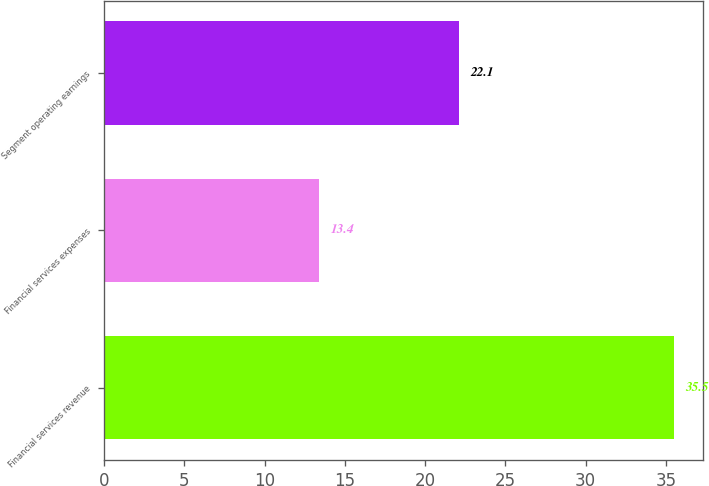Convert chart to OTSL. <chart><loc_0><loc_0><loc_500><loc_500><bar_chart><fcel>Financial services revenue<fcel>Financial services expenses<fcel>Segment operating earnings<nl><fcel>35.5<fcel>13.4<fcel>22.1<nl></chart> 